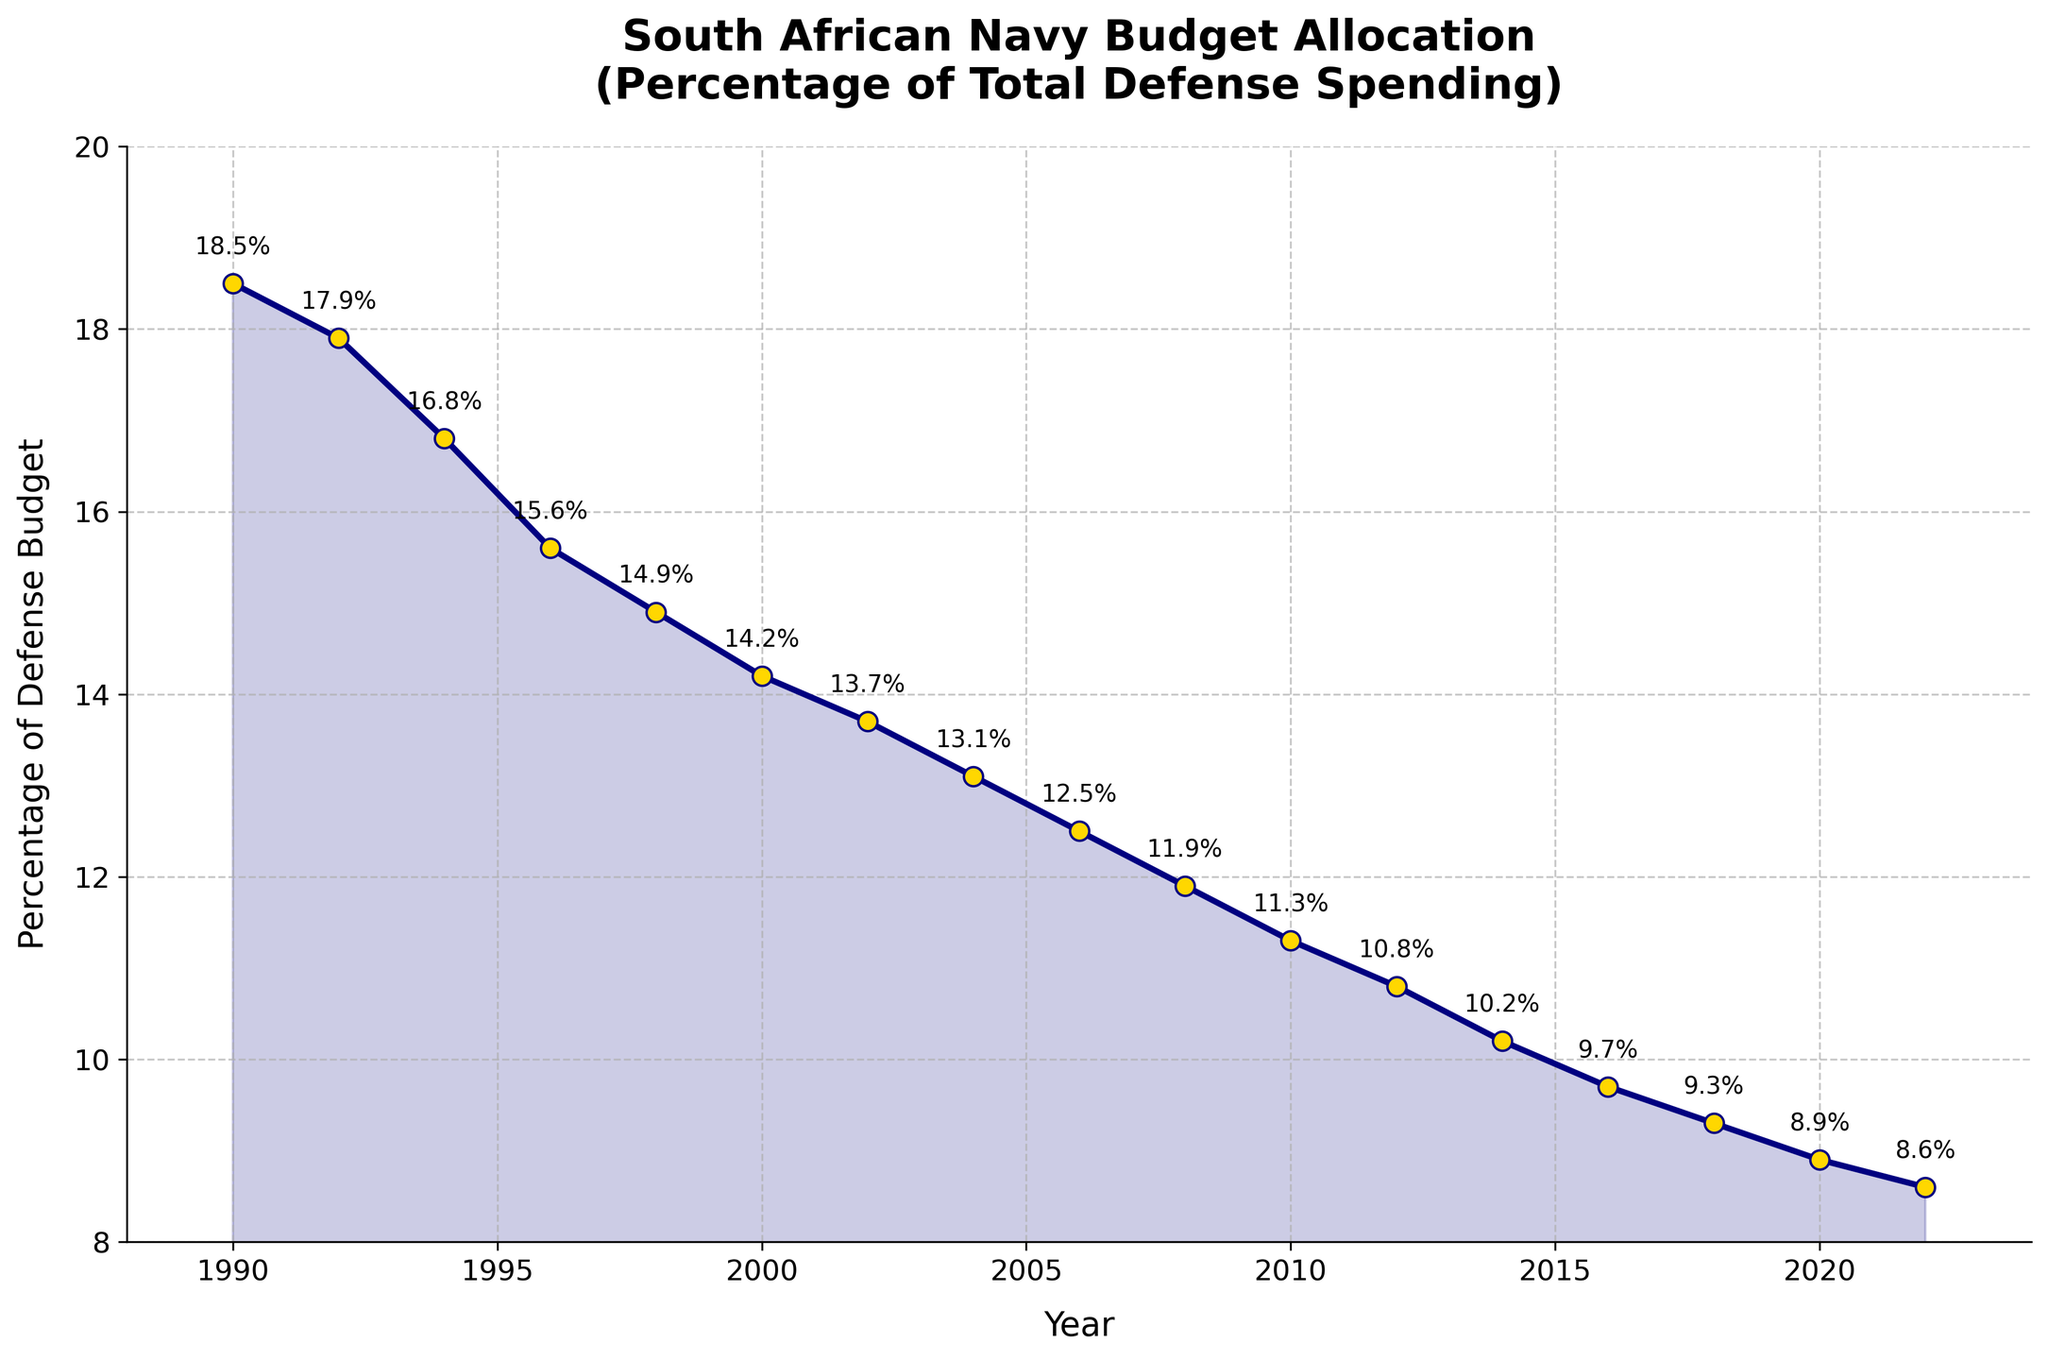What is the general trend of the percentage of the total defense budget allocated to the South African Navy from 1990 to 2022? The line chart shows a continuous decline in the percentage allocated to the South African Navy. Starting from 18.5% in 1990 down to 8.6% in 2022, the percentage has consistently decreased over the years.
Answer: Continuous decline In which year was the highest percentage of the total defense budget allocated to the South African Navy? According to the chart, the highest percentage was in the year 1990, with 18.5%.
Answer: 1990 Compare the percentage allocations in 2000 and 2020. Which year had a greater percentage, and by how much? In 2000, the percentage was 14.2%, while in 2020 it was 8.9%. 2000 had a greater percentage by 14.2% - 8.9% = 5.3%.
Answer: 2000, by 5.3% What is the percentage change in budget allocation from 1990 to 2022? The percentage in 1990 was 18.5%, and in 2022 it was 8.6%. The change is calculated as 18.5% - 8.6% = 9.9%.
Answer: Decrease by 9.9% Identify the year with the smallest percentage drop compared to its previous data point. Observing the chart, the smallest drop occurred between 2020 (8.9%) and 2022 (8.6%). The difference is 0.3%.
Answer: 2022 How does the percentage in 1998 compare to that in 2002? In 1998, the percentage was 14.9%, and in 2002 it was 13.7%. The percentage in 1998 was higher by 14.9% - 13.7% = 1.2%.
Answer: 1998, by 1.2% What is the average percentage of the total defense budget allocated to the South African Navy from 1990 to 2022? There are 17 data points. Calculating the average: (18.5 + 17.9 + 16.8 + 15.6 + 14.9 + 14.2 + 13.7 + 13.1 + 12.5 + 11.9 + 11.3 + 10.8 + 10.2 + 9.7 + 9.3 + 8.9 + 8.6)/17 = 12.92% (rounded to two decimal places).
Answer: 12.92% Which year had the largest drop in percentage allocation compared to the previous year? The largest drop occurred between 1990 (18.5%) and 1992 (17.9%). The difference is 0.6%.
Answer: Between 1990 and 1992 What visual elements emphasize the declining trend in the chart? The downward sloping line plot and the fill area below the line, shaded in teal, accentuate the continuous decline in the budget allocation percentages over the years.
Answer: Downward sloping line, shaded fill area 